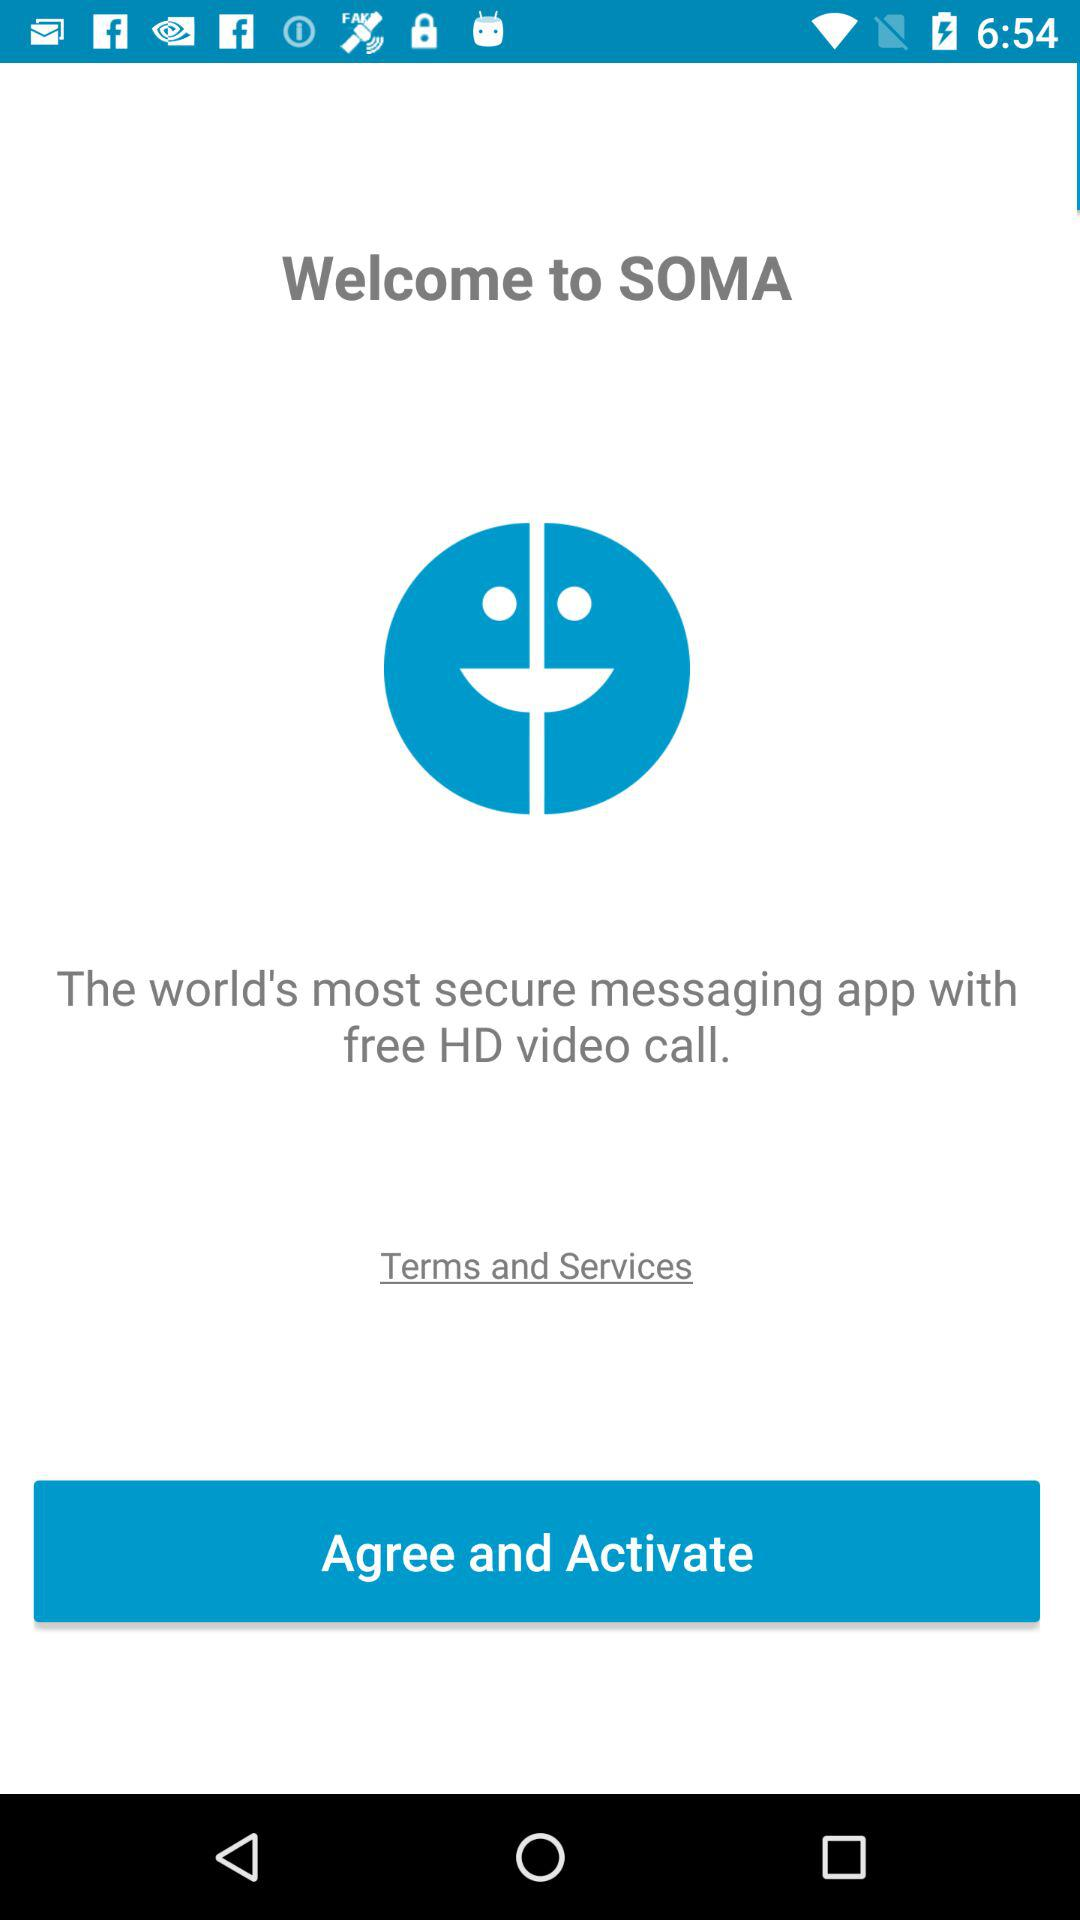What is the application name? The application name is "SOMA". 